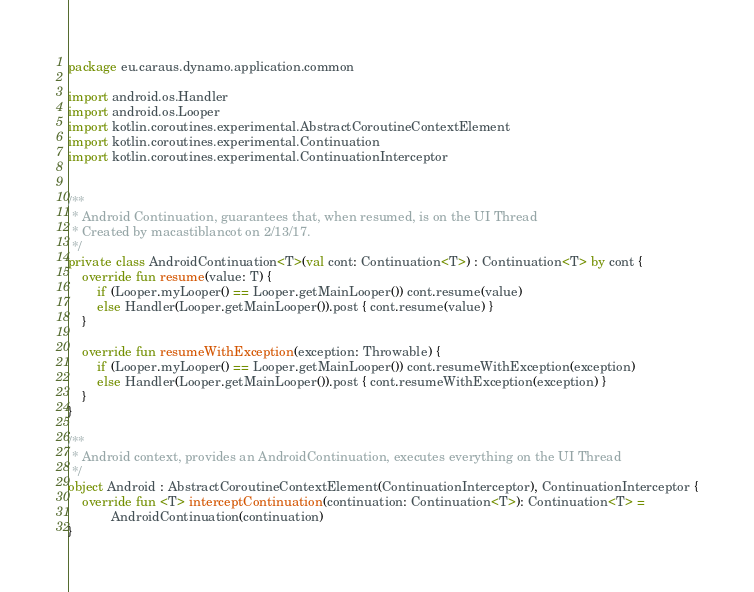<code> <loc_0><loc_0><loc_500><loc_500><_Kotlin_>package eu.caraus.dynamo.application.common

import android.os.Handler
import android.os.Looper
import kotlin.coroutines.experimental.AbstractCoroutineContextElement
import kotlin.coroutines.experimental.Continuation
import kotlin.coroutines.experimental.ContinuationInterceptor


/**
 * Android Continuation, guarantees that, when resumed, is on the UI Thread
 * Created by macastiblancot on 2/13/17.
 */
private class AndroidContinuation<T>(val cont: Continuation<T>) : Continuation<T> by cont {
    override fun resume(value: T) {
        if (Looper.myLooper() == Looper.getMainLooper()) cont.resume(value)
        else Handler(Looper.getMainLooper()).post { cont.resume(value) }
    }

    override fun resumeWithException(exception: Throwable) {
        if (Looper.myLooper() == Looper.getMainLooper()) cont.resumeWithException(exception)
        else Handler(Looper.getMainLooper()).post { cont.resumeWithException(exception) }
    }
}

/**
 * Android context, provides an AndroidContinuation, executes everything on the UI Thread
 */
object Android : AbstractCoroutineContextElement(ContinuationInterceptor), ContinuationInterceptor {
    override fun <T> interceptContinuation(continuation: Continuation<T>): Continuation<T> =
            AndroidContinuation(continuation)
}
</code> 